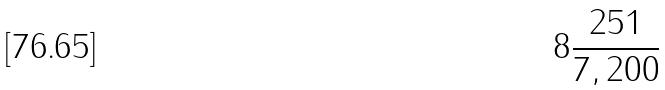<formula> <loc_0><loc_0><loc_500><loc_500>8 \frac { 2 5 1 } { 7 , 2 0 0 }</formula> 